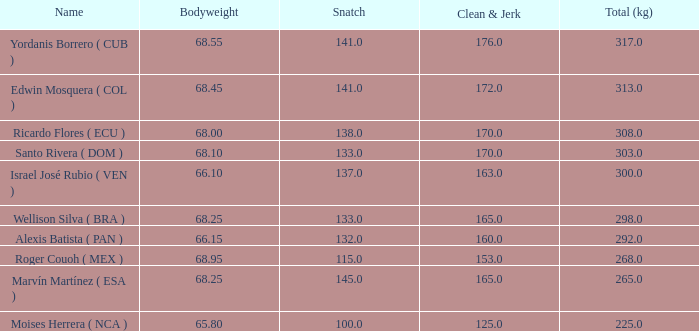Which total (kg) has a clean & jerk less than 153, and a snatch less than 100? None. 